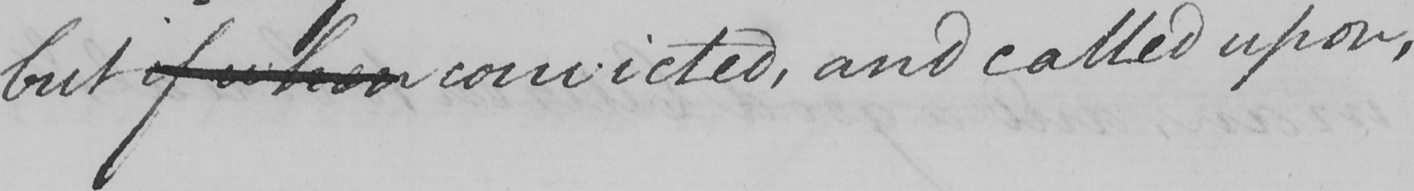What text is written in this handwritten line? but if when convicted , and called upon , 